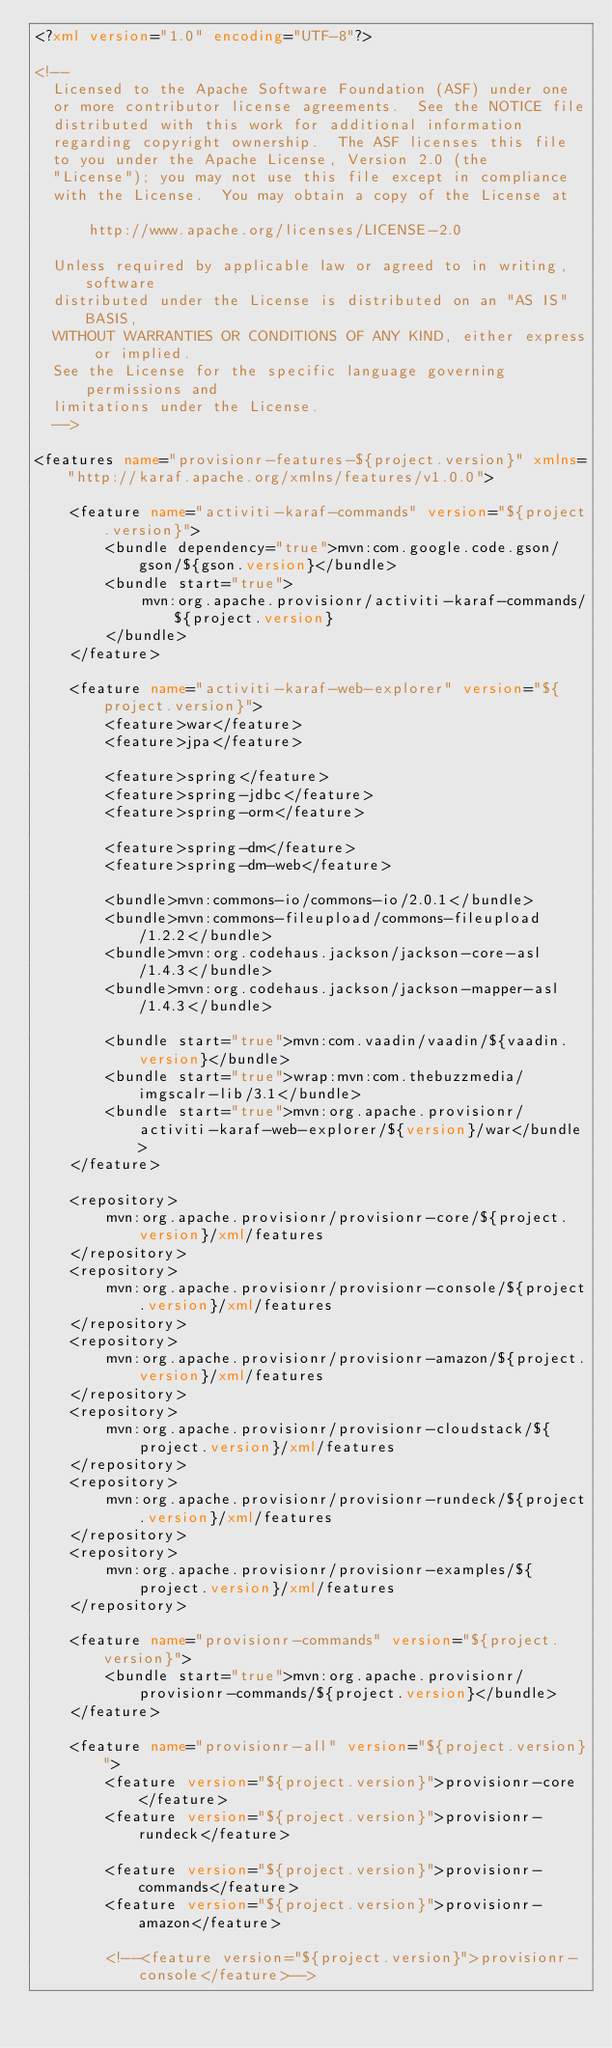<code> <loc_0><loc_0><loc_500><loc_500><_XML_><?xml version="1.0" encoding="UTF-8"?>

<!--
  Licensed to the Apache Software Foundation (ASF) under one
  or more contributor license agreements.  See the NOTICE file
  distributed with this work for additional information
  regarding copyright ownership.  The ASF licenses this file
  to you under the Apache License, Version 2.0 (the
  "License"); you may not use this file except in compliance
  with the License.  You may obtain a copy of the License at

      http://www.apache.org/licenses/LICENSE-2.0

  Unless required by applicable law or agreed to in writing, software
  distributed under the License is distributed on an "AS IS" BASIS,
  WITHOUT WARRANTIES OR CONDITIONS OF ANY KIND, either express or implied.
  See the License for the specific language governing permissions and
  limitations under the License.
  -->

<features name="provisionr-features-${project.version}" xmlns="http://karaf.apache.org/xmlns/features/v1.0.0">

    <feature name="activiti-karaf-commands" version="${project.version}">
        <bundle dependency="true">mvn:com.google.code.gson/gson/${gson.version}</bundle>
        <bundle start="true">
            mvn:org.apache.provisionr/activiti-karaf-commands/${project.version}
        </bundle>
    </feature>

    <feature name="activiti-karaf-web-explorer" version="${project.version}">
        <feature>war</feature>
        <feature>jpa</feature>

        <feature>spring</feature>
        <feature>spring-jdbc</feature>
        <feature>spring-orm</feature>

        <feature>spring-dm</feature>
        <feature>spring-dm-web</feature>

        <bundle>mvn:commons-io/commons-io/2.0.1</bundle>
        <bundle>mvn:commons-fileupload/commons-fileupload/1.2.2</bundle>
        <bundle>mvn:org.codehaus.jackson/jackson-core-asl/1.4.3</bundle>
        <bundle>mvn:org.codehaus.jackson/jackson-mapper-asl/1.4.3</bundle>

        <bundle start="true">mvn:com.vaadin/vaadin/${vaadin.version}</bundle>
        <bundle start="true">wrap:mvn:com.thebuzzmedia/imgscalr-lib/3.1</bundle>
        <bundle start="true">mvn:org.apache.provisionr/activiti-karaf-web-explorer/${version}/war</bundle>
    </feature>

    <repository>
        mvn:org.apache.provisionr/provisionr-core/${project.version}/xml/features
    </repository>
    <repository>
        mvn:org.apache.provisionr/provisionr-console/${project.version}/xml/features
    </repository>
    <repository>
        mvn:org.apache.provisionr/provisionr-amazon/${project.version}/xml/features
    </repository>
    <repository>
        mvn:org.apache.provisionr/provisionr-cloudstack/${project.version}/xml/features
    </repository>
    <repository>
        mvn:org.apache.provisionr/provisionr-rundeck/${project.version}/xml/features
    </repository>
    <repository>
        mvn:org.apache.provisionr/provisionr-examples/${project.version}/xml/features
    </repository>

    <feature name="provisionr-commands" version="${project.version}">
        <bundle start="true">mvn:org.apache.provisionr/provisionr-commands/${project.version}</bundle>
    </feature>

    <feature name="provisionr-all" version="${project.version}">
        <feature version="${project.version}">provisionr-core</feature>
        <feature version="${project.version}">provisionr-rundeck</feature>

        <feature version="${project.version}">provisionr-commands</feature>
        <feature version="${project.version}">provisionr-amazon</feature>

        <!--<feature version="${project.version}">provisionr-console</feature>--></code> 